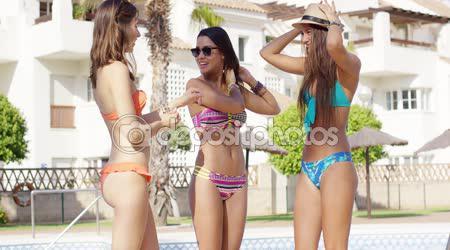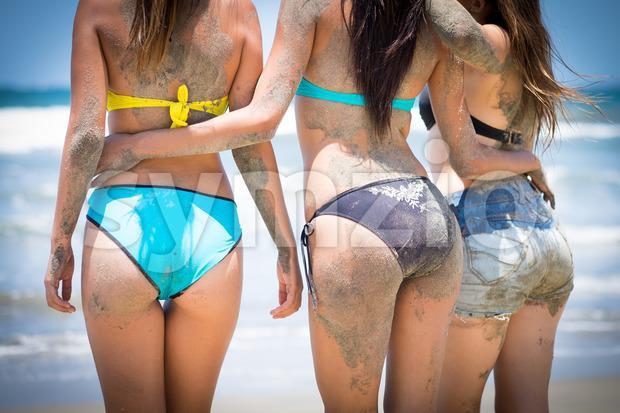The first image is the image on the left, the second image is the image on the right. For the images shown, is this caption "In at least one image you can see a single woman in a all pink bikini with no additional colors on her suit." true? Answer yes or no. No. The first image is the image on the left, the second image is the image on the right. Considering the images on both sides, is "An image shows three bikini models side-by-side with backs turned to the camera." valid? Answer yes or no. Yes. 